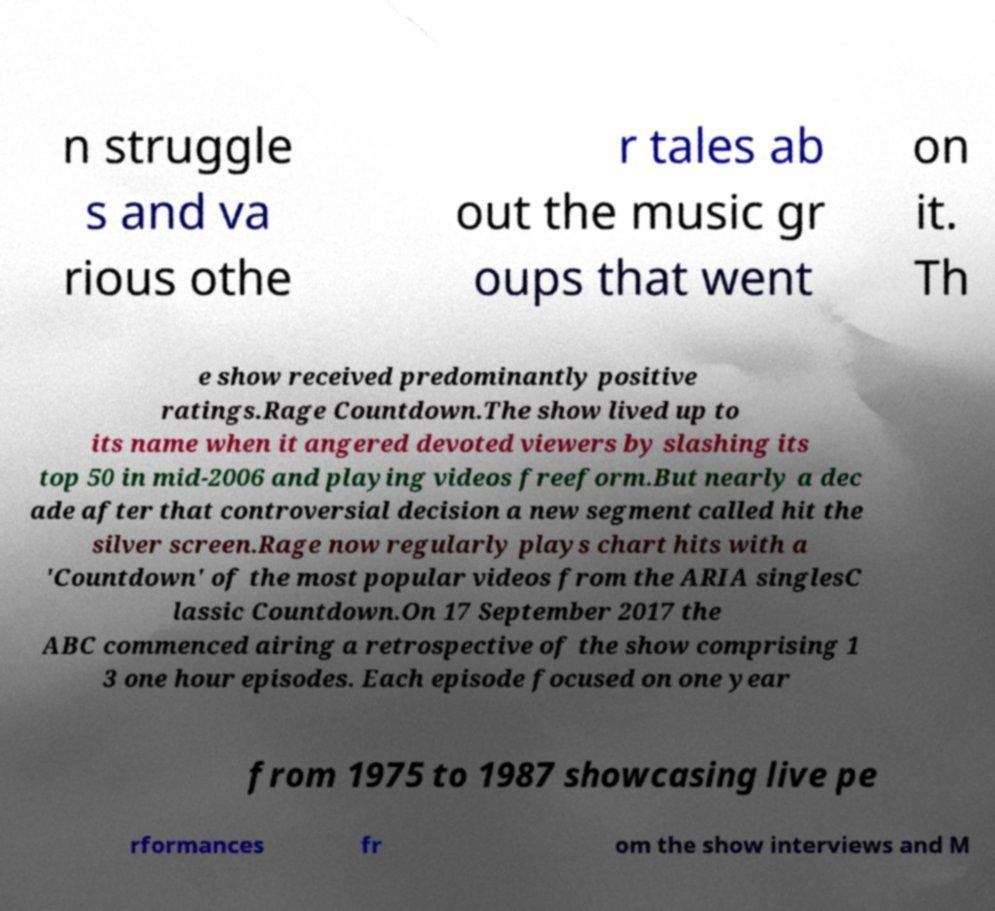Can you accurately transcribe the text from the provided image for me? n struggle s and va rious othe r tales ab out the music gr oups that went on it. Th e show received predominantly positive ratings.Rage Countdown.The show lived up to its name when it angered devoted viewers by slashing its top 50 in mid-2006 and playing videos freeform.But nearly a dec ade after that controversial decision a new segment called hit the silver screen.Rage now regularly plays chart hits with a 'Countdown' of the most popular videos from the ARIA singlesC lassic Countdown.On 17 September 2017 the ABC commenced airing a retrospective of the show comprising 1 3 one hour episodes. Each episode focused on one year from 1975 to 1987 showcasing live pe rformances fr om the show interviews and M 